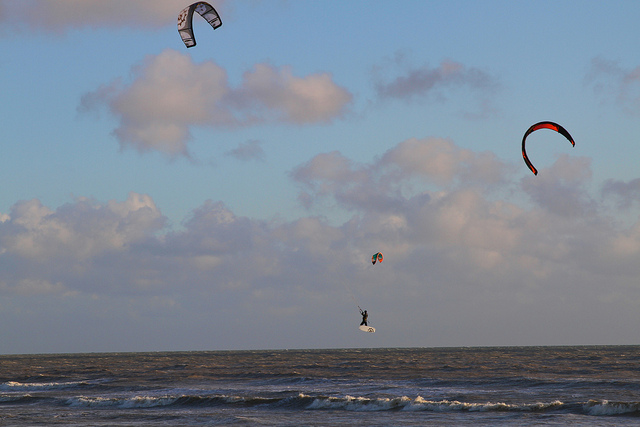Are there any humans visible in the image? Yes, amidst the natural splendor, one can spot a singular human figure engaged in the thrilling sport of kite surfing, gracefully balanced on the precipice between sea and sky. 